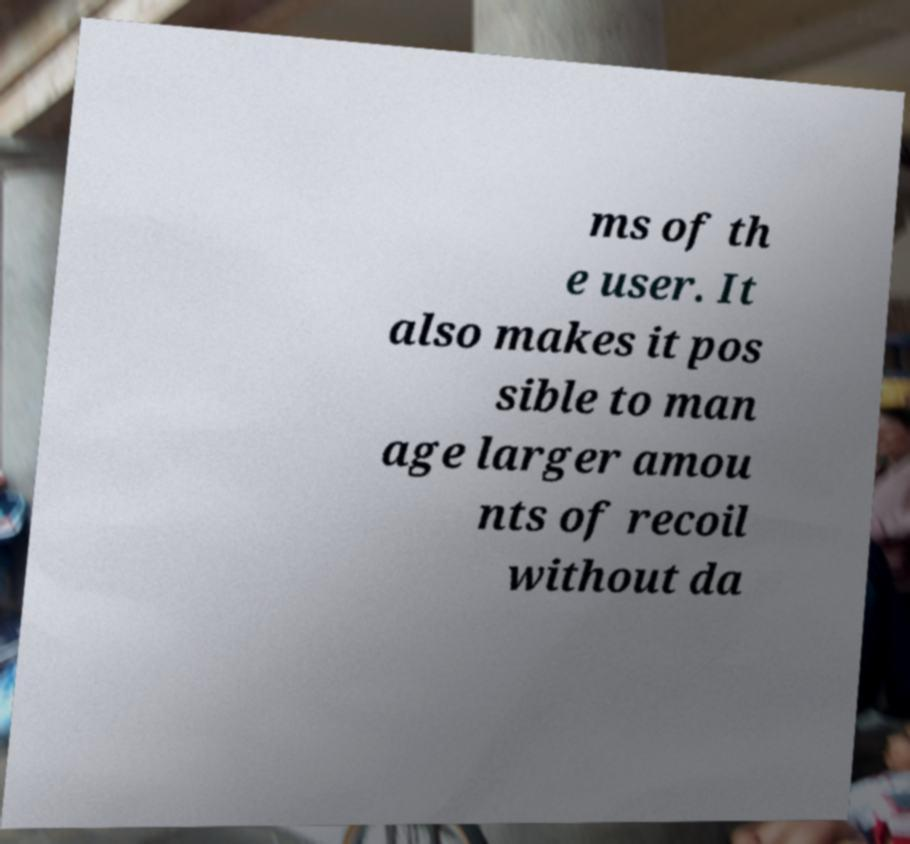Could you extract and type out the text from this image? ms of th e user. It also makes it pos sible to man age larger amou nts of recoil without da 